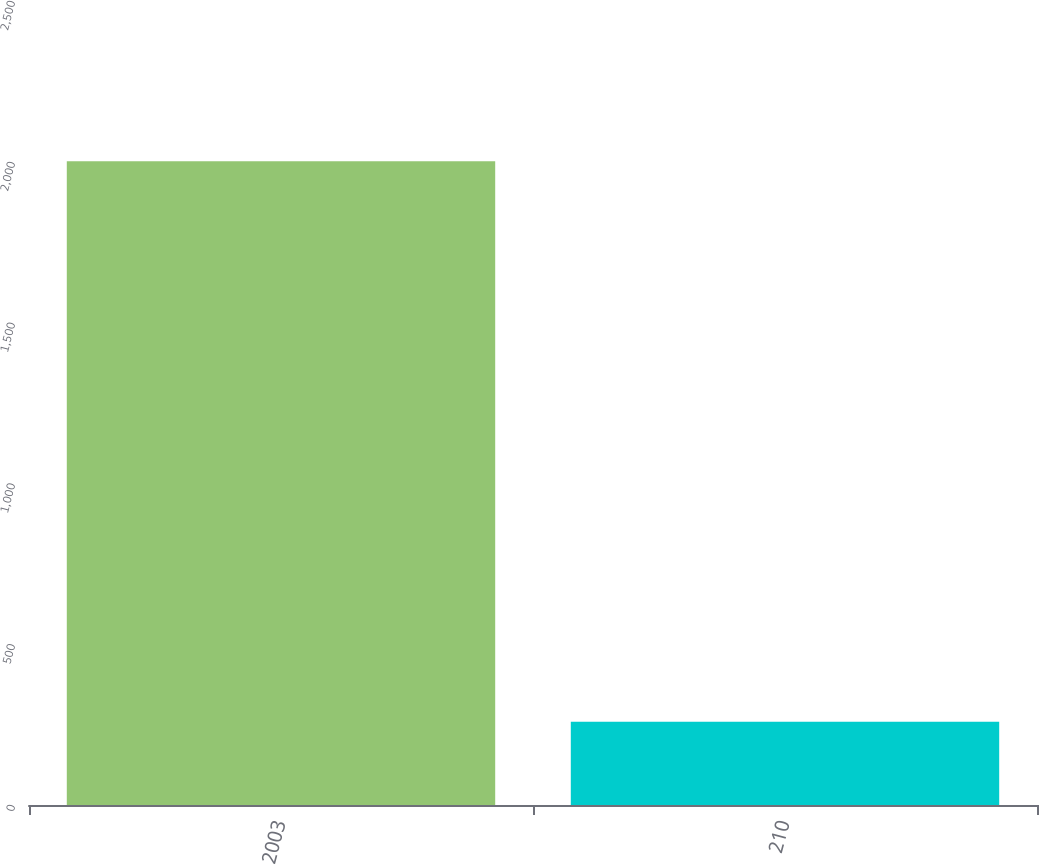Convert chart to OTSL. <chart><loc_0><loc_0><loc_500><loc_500><bar_chart><fcel>2003<fcel>210<nl><fcel>2002<fcel>259<nl></chart> 